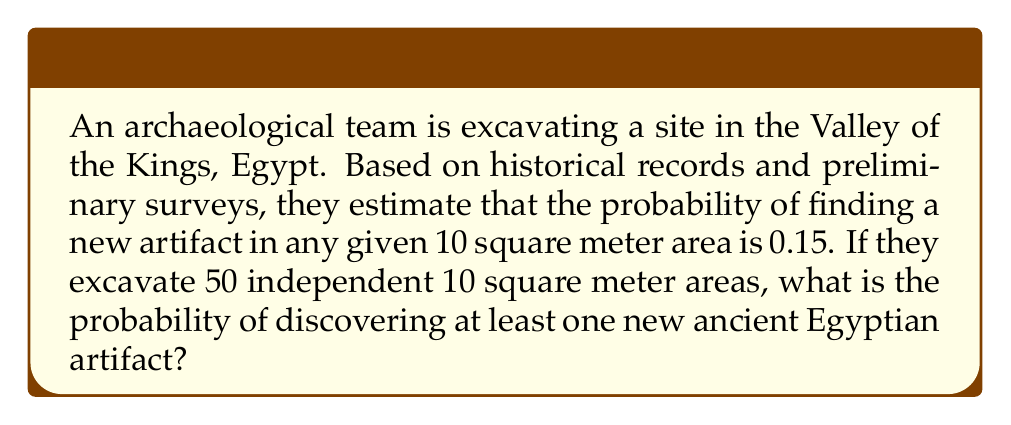Can you solve this math problem? To solve this problem, we can use the complement rule of probability. Let's break it down step-by-step:

1) First, let's define our events:
   Let A = the event of discovering at least one new artifact
   Let B = the event of not discovering any new artifacts

2) We want to find P(A), but it's easier to calculate P(B) and then use the complement rule:
   P(A) = 1 - P(B)

3) The probability of not finding an artifact in one 10 square meter area is:
   1 - 0.15 = 0.85

4) For 50 independent areas, the probability of not finding an artifact in any of them is:
   P(B) = $(0.85)^{50}$

5) Now we can calculate P(A):
   P(A) = 1 - P(B) = 1 - $(0.85)^{50}$

6) Let's calculate this:
   $(0.85)^{50} \approx 0.0000293$
   
   1 - 0.0000293 = 0.9999707

7) Converting to a percentage:
   0.9999707 * 100% ≈ 99.997%

Therefore, the probability of discovering at least one new ancient Egyptian artifact is approximately 99.997%.
Answer: The probability of discovering at least one new ancient Egyptian artifact during the excavation is approximately 99.997%. 